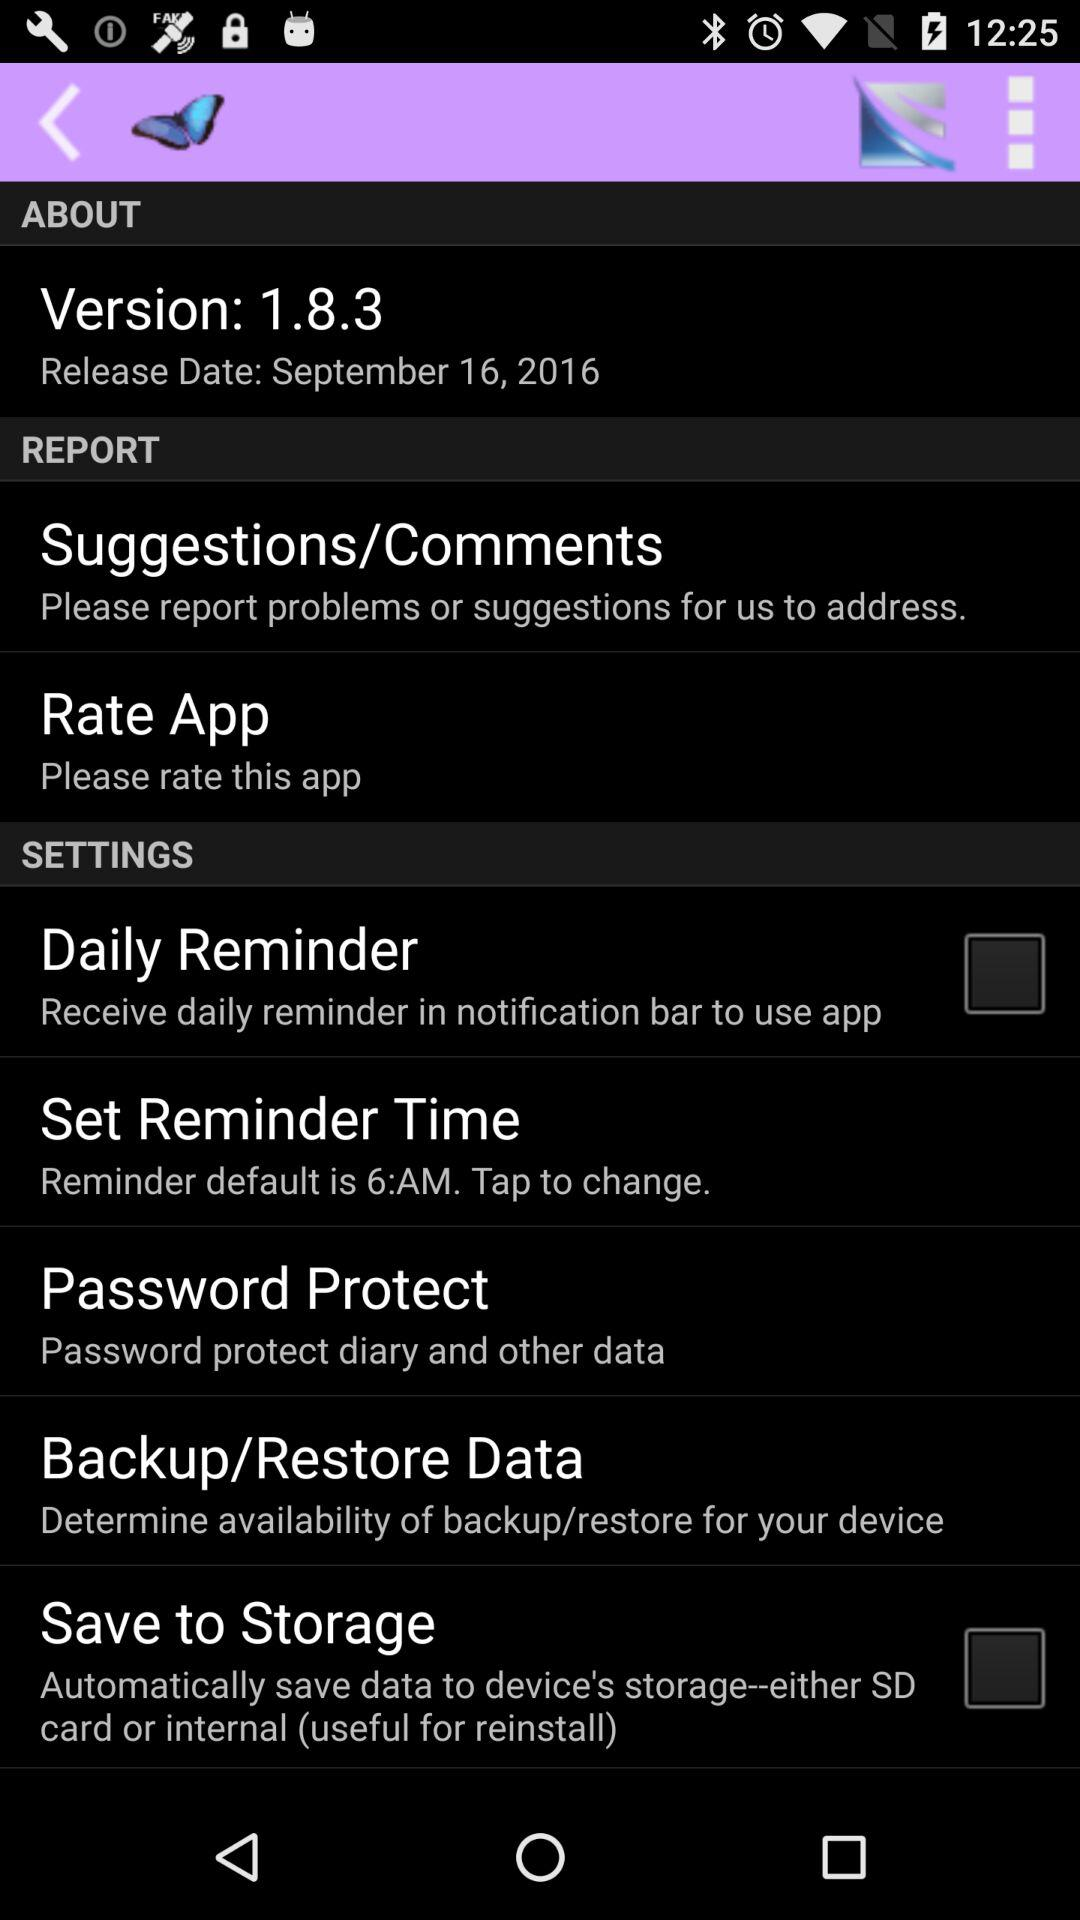What is the release date of version 1.8.3? The release date is September 16, 2016. 